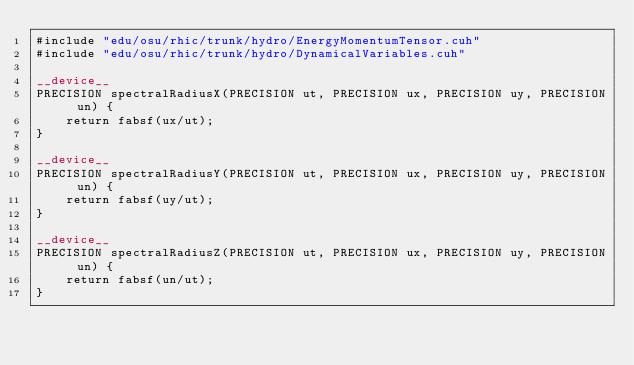<code> <loc_0><loc_0><loc_500><loc_500><_Cuda_>#include "edu/osu/rhic/trunk/hydro/EnergyMomentumTensor.cuh"
#include "edu/osu/rhic/trunk/hydro/DynamicalVariables.cuh"

__device__ 
PRECISION spectralRadiusX(PRECISION ut, PRECISION ux, PRECISION uy, PRECISION un) {
	return fabsf(ux/ut);
}

__device__ 
PRECISION spectralRadiusY(PRECISION ut, PRECISION ux, PRECISION uy, PRECISION un) {
	return fabsf(uy/ut);
}

__device__ 
PRECISION spectralRadiusZ(PRECISION ut, PRECISION ux, PRECISION uy, PRECISION un) {
	return fabsf(un/ut);
}
</code> 